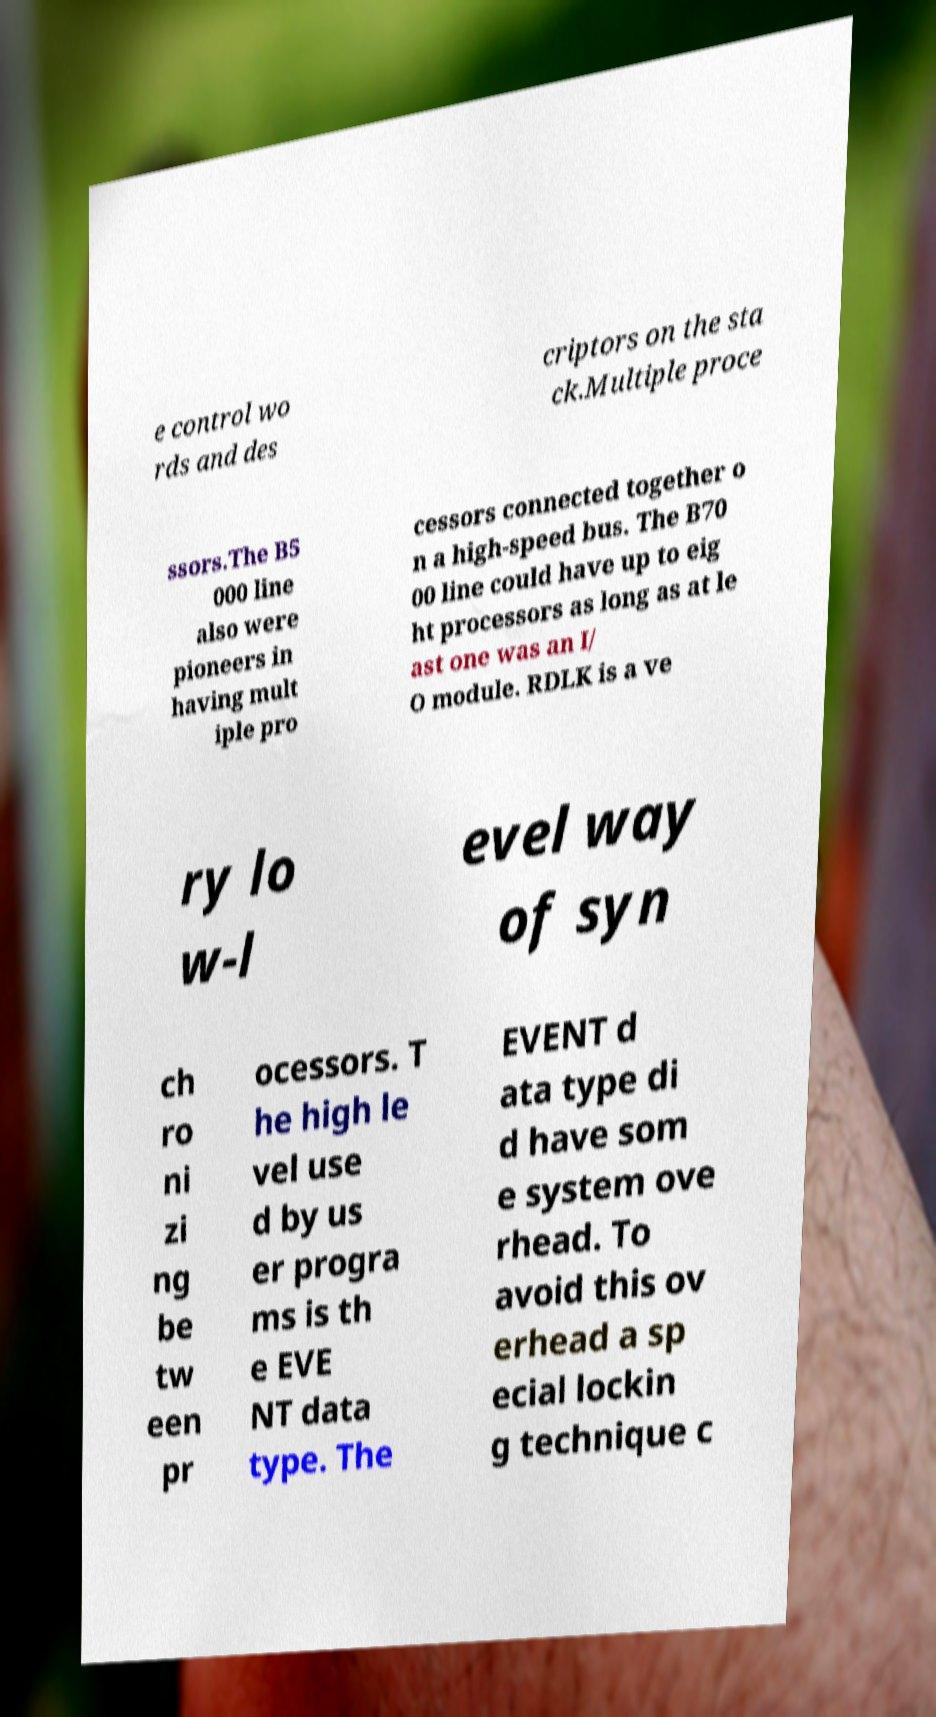Could you assist in decoding the text presented in this image and type it out clearly? e control wo rds and des criptors on the sta ck.Multiple proce ssors.The B5 000 line also were pioneers in having mult iple pro cessors connected together o n a high-speed bus. The B70 00 line could have up to eig ht processors as long as at le ast one was an I/ O module. RDLK is a ve ry lo w-l evel way of syn ch ro ni zi ng be tw een pr ocessors. T he high le vel use d by us er progra ms is th e EVE NT data type. The EVENT d ata type di d have som e system ove rhead. To avoid this ov erhead a sp ecial lockin g technique c 